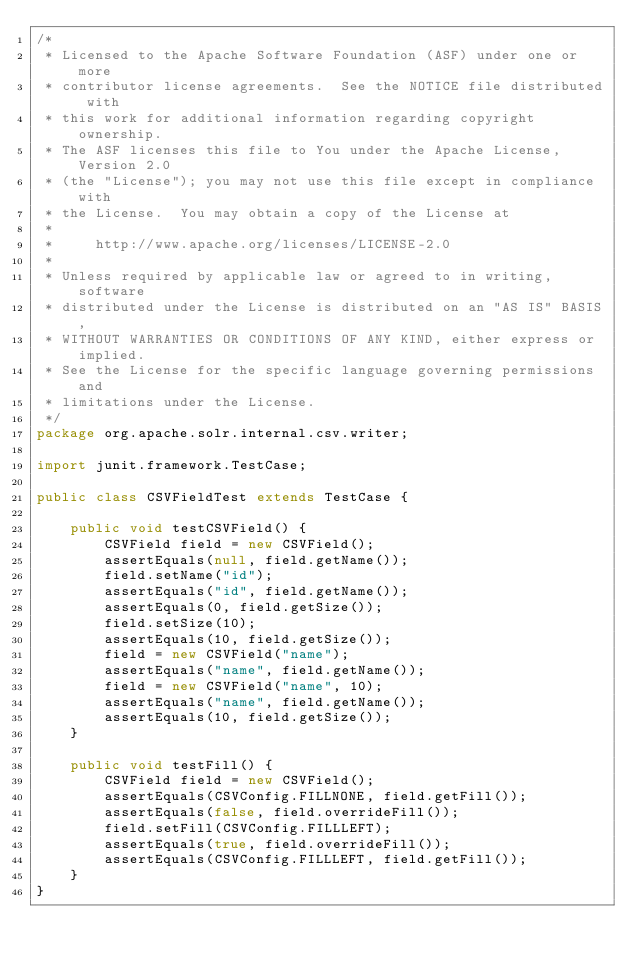<code> <loc_0><loc_0><loc_500><loc_500><_Java_>/*
 * Licensed to the Apache Software Foundation (ASF) under one or more
 * contributor license agreements.  See the NOTICE file distributed with
 * this work for additional information regarding copyright ownership.
 * The ASF licenses this file to You under the Apache License, Version 2.0
 * (the "License"); you may not use this file except in compliance with
 * the License.  You may obtain a copy of the License at
 *
 *     http://www.apache.org/licenses/LICENSE-2.0
 *
 * Unless required by applicable law or agreed to in writing, software
 * distributed under the License is distributed on an "AS IS" BASIS,
 * WITHOUT WARRANTIES OR CONDITIONS OF ANY KIND, either express or implied.
 * See the License for the specific language governing permissions and
 * limitations under the License.
 */
package org.apache.solr.internal.csv.writer;

import junit.framework.TestCase;

public class CSVFieldTest extends TestCase {

    public void testCSVField() {
        CSVField field = new CSVField();
        assertEquals(null, field.getName());
        field.setName("id");
        assertEquals("id", field.getName());
        assertEquals(0, field.getSize());
        field.setSize(10);
        assertEquals(10, field.getSize());
        field = new CSVField("name");
        assertEquals("name", field.getName());
        field = new CSVField("name", 10);
        assertEquals("name", field.getName());
        assertEquals(10, field.getSize());
    }
    
    public void testFill() {
        CSVField field = new CSVField();
        assertEquals(CSVConfig.FILLNONE, field.getFill());
        assertEquals(false, field.overrideFill());
        field.setFill(CSVConfig.FILLLEFT);
        assertEquals(true, field.overrideFill());
        assertEquals(CSVConfig.FILLLEFT, field.getFill());
    }
}
</code> 